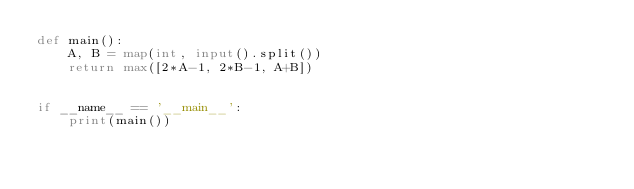Convert code to text. <code><loc_0><loc_0><loc_500><loc_500><_Python_>def main():
    A, B = map(int, input().split())
    return max([2*A-1, 2*B-1, A+B])


if __name__ == '__main__':
    print(main())</code> 